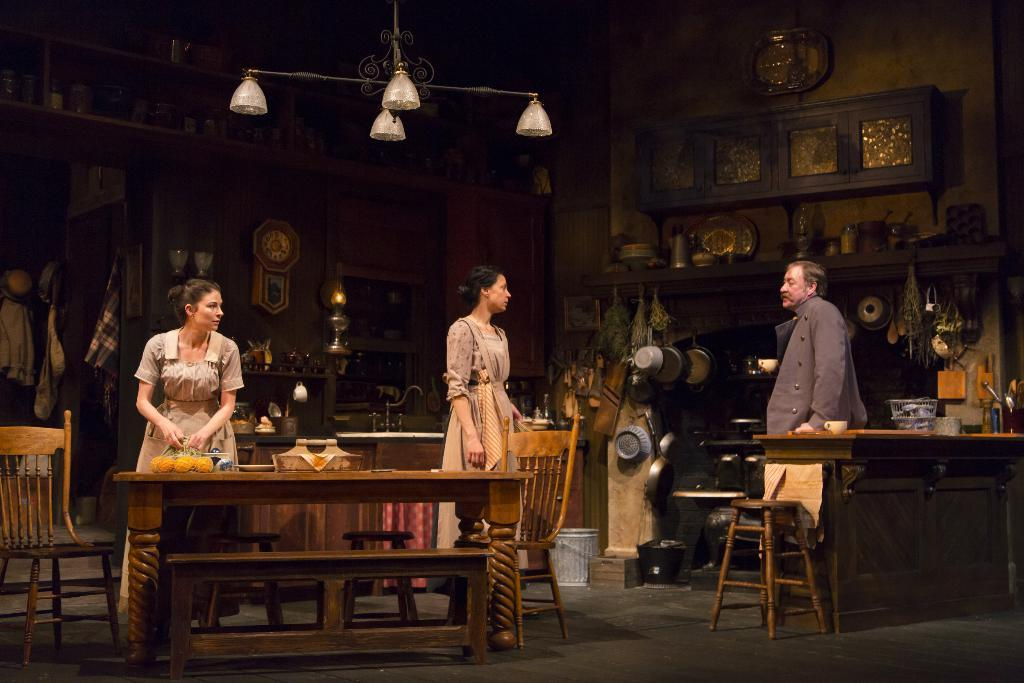How many people are present in the image? There are three people in the image. What is the woman holding in the image? The woman is holding a bag in the image. What type of furniture is present in the image? There is a table and chairs in the image. What objects can be seen on the table? There are vessels on the table in the image. What type of cent can be seen on the table in the image? There is no cent present on the table in the image. How does the steam escape from the vessels in the image? There is no steam present in the image; it is not mentioned in the provided facts. 